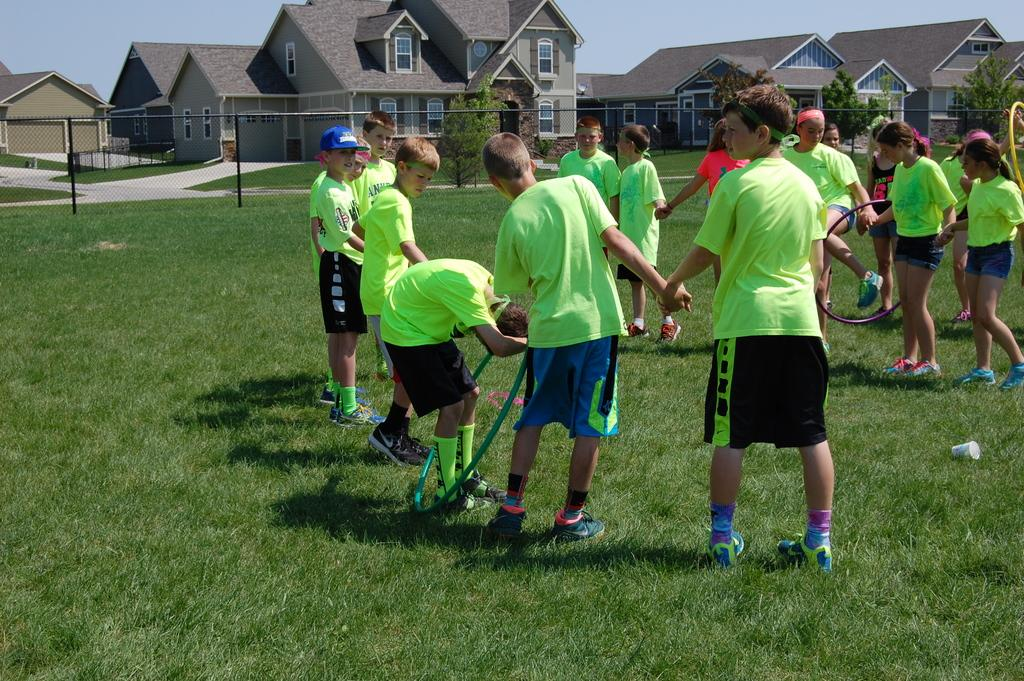What activity are the people in the image engaged in? The people in the image are playing with rings. What is the surface they are playing on? The surface they are playing on is grass. What can be seen in the background of the image? There is a net fence, buildings, trees, and the sky visible in the background of the image. What type of vase can be seen on the grass in the image? There is no vase present on the grass in the image. How many chairs are visible in the image? There are no chairs visible in the image. 